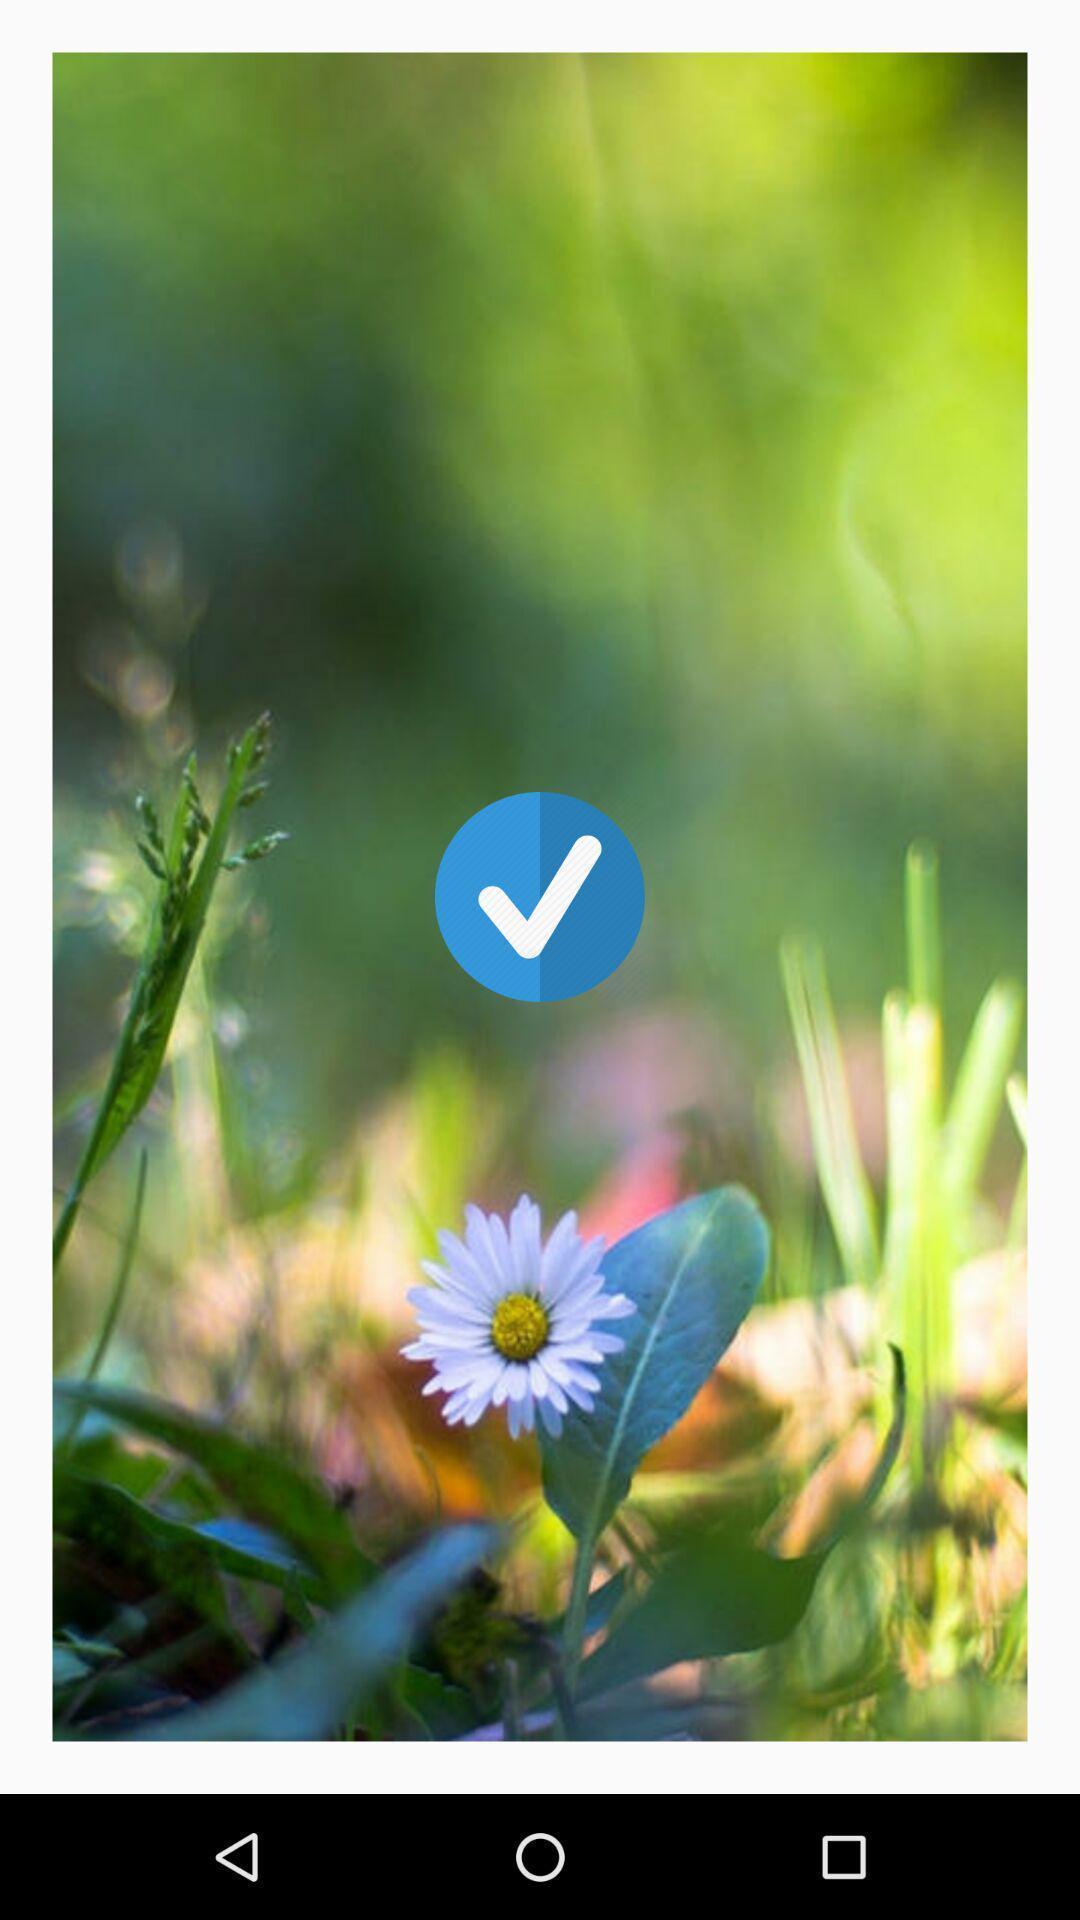Tell me what you see in this picture. Page showing tick symbol. 